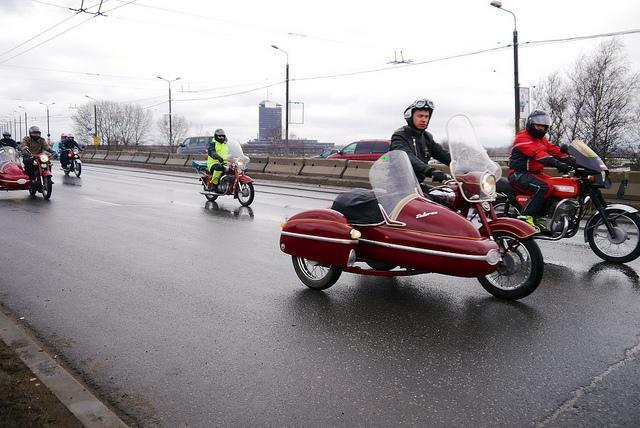How many motorcycles are there?
Give a very brief answer. 3. How many people are visible?
Give a very brief answer. 2. 